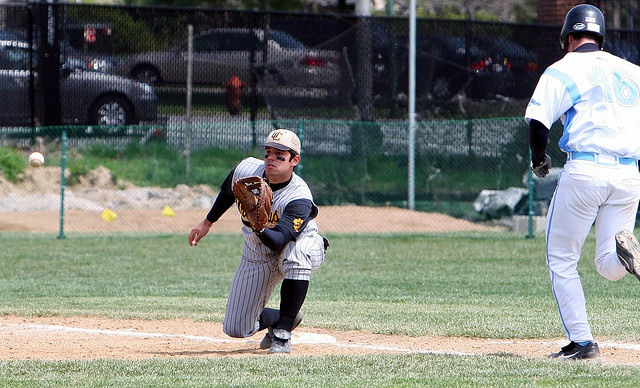Describe the objects in this image and their specific colors. I can see people in darkgray, lavender, and black tones, people in darkgray, black, gray, and lightgray tones, car in darkgray, black, and gray tones, car in darkgray, black, gray, and blue tones, and car in darkgray, black, gray, and maroon tones in this image. 